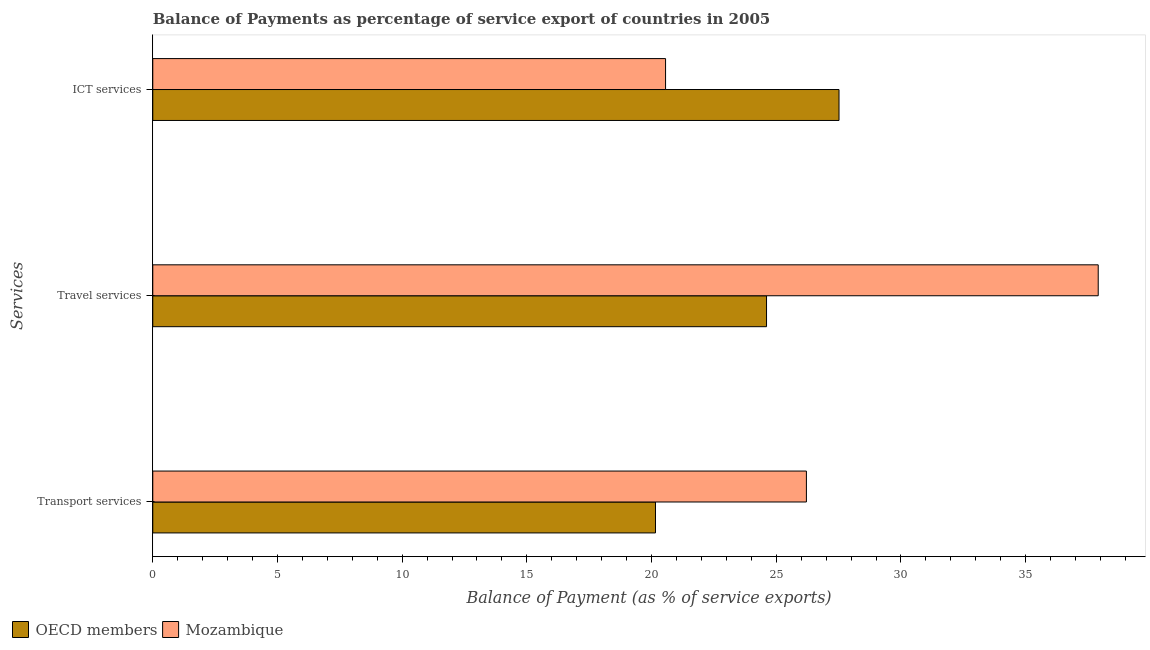How many groups of bars are there?
Keep it short and to the point. 3. Are the number of bars per tick equal to the number of legend labels?
Your answer should be very brief. Yes. Are the number of bars on each tick of the Y-axis equal?
Make the answer very short. Yes. What is the label of the 3rd group of bars from the top?
Your response must be concise. Transport services. What is the balance of payment of ict services in OECD members?
Offer a terse response. 27.52. Across all countries, what is the maximum balance of payment of travel services?
Your answer should be very brief. 37.91. Across all countries, what is the minimum balance of payment of travel services?
Ensure brevity in your answer.  24.61. In which country was the balance of payment of transport services maximum?
Keep it short and to the point. Mozambique. In which country was the balance of payment of travel services minimum?
Offer a very short reply. OECD members. What is the total balance of payment of ict services in the graph?
Provide a short and direct response. 48.08. What is the difference between the balance of payment of transport services in OECD members and that in Mozambique?
Provide a succinct answer. -6.05. What is the difference between the balance of payment of transport services in Mozambique and the balance of payment of travel services in OECD members?
Keep it short and to the point. 1.6. What is the average balance of payment of ict services per country?
Ensure brevity in your answer.  24.04. What is the difference between the balance of payment of transport services and balance of payment of travel services in OECD members?
Your response must be concise. -4.45. What is the ratio of the balance of payment of ict services in OECD members to that in Mozambique?
Make the answer very short. 1.34. Is the difference between the balance of payment of ict services in Mozambique and OECD members greater than the difference between the balance of payment of transport services in Mozambique and OECD members?
Your answer should be compact. No. What is the difference between the highest and the second highest balance of payment of travel services?
Give a very brief answer. 13.3. What is the difference between the highest and the lowest balance of payment of travel services?
Provide a short and direct response. 13.3. In how many countries, is the balance of payment of transport services greater than the average balance of payment of transport services taken over all countries?
Provide a succinct answer. 1. What does the 1st bar from the bottom in ICT services represents?
Your answer should be very brief. OECD members. Is it the case that in every country, the sum of the balance of payment of transport services and balance of payment of travel services is greater than the balance of payment of ict services?
Offer a terse response. Yes. How many bars are there?
Give a very brief answer. 6. Are all the bars in the graph horizontal?
Make the answer very short. Yes. Are the values on the major ticks of X-axis written in scientific E-notation?
Make the answer very short. No. Does the graph contain grids?
Make the answer very short. No. Where does the legend appear in the graph?
Offer a very short reply. Bottom left. How many legend labels are there?
Your answer should be very brief. 2. What is the title of the graph?
Provide a short and direct response. Balance of Payments as percentage of service export of countries in 2005. Does "Romania" appear as one of the legend labels in the graph?
Your response must be concise. No. What is the label or title of the X-axis?
Provide a short and direct response. Balance of Payment (as % of service exports). What is the label or title of the Y-axis?
Your answer should be compact. Services. What is the Balance of Payment (as % of service exports) of OECD members in Transport services?
Make the answer very short. 20.16. What is the Balance of Payment (as % of service exports) in Mozambique in Transport services?
Make the answer very short. 26.21. What is the Balance of Payment (as % of service exports) in OECD members in Travel services?
Offer a terse response. 24.61. What is the Balance of Payment (as % of service exports) in Mozambique in Travel services?
Keep it short and to the point. 37.91. What is the Balance of Payment (as % of service exports) in OECD members in ICT services?
Your answer should be very brief. 27.52. What is the Balance of Payment (as % of service exports) of Mozambique in ICT services?
Keep it short and to the point. 20.56. Across all Services, what is the maximum Balance of Payment (as % of service exports) in OECD members?
Your answer should be very brief. 27.52. Across all Services, what is the maximum Balance of Payment (as % of service exports) of Mozambique?
Make the answer very short. 37.91. Across all Services, what is the minimum Balance of Payment (as % of service exports) of OECD members?
Your answer should be compact. 20.16. Across all Services, what is the minimum Balance of Payment (as % of service exports) in Mozambique?
Make the answer very short. 20.56. What is the total Balance of Payment (as % of service exports) of OECD members in the graph?
Ensure brevity in your answer.  72.29. What is the total Balance of Payment (as % of service exports) of Mozambique in the graph?
Offer a very short reply. 84.68. What is the difference between the Balance of Payment (as % of service exports) in OECD members in Transport services and that in Travel services?
Provide a succinct answer. -4.45. What is the difference between the Balance of Payment (as % of service exports) of Mozambique in Transport services and that in Travel services?
Give a very brief answer. -11.7. What is the difference between the Balance of Payment (as % of service exports) in OECD members in Transport services and that in ICT services?
Make the answer very short. -7.36. What is the difference between the Balance of Payment (as % of service exports) in Mozambique in Transport services and that in ICT services?
Ensure brevity in your answer.  5.65. What is the difference between the Balance of Payment (as % of service exports) in OECD members in Travel services and that in ICT services?
Your response must be concise. -2.91. What is the difference between the Balance of Payment (as % of service exports) in Mozambique in Travel services and that in ICT services?
Give a very brief answer. 17.35. What is the difference between the Balance of Payment (as % of service exports) in OECD members in Transport services and the Balance of Payment (as % of service exports) in Mozambique in Travel services?
Keep it short and to the point. -17.75. What is the difference between the Balance of Payment (as % of service exports) in OECD members in Transport services and the Balance of Payment (as % of service exports) in Mozambique in ICT services?
Give a very brief answer. -0.4. What is the difference between the Balance of Payment (as % of service exports) of OECD members in Travel services and the Balance of Payment (as % of service exports) of Mozambique in ICT services?
Your answer should be compact. 4.05. What is the average Balance of Payment (as % of service exports) in OECD members per Services?
Your answer should be compact. 24.1. What is the average Balance of Payment (as % of service exports) of Mozambique per Services?
Provide a short and direct response. 28.23. What is the difference between the Balance of Payment (as % of service exports) of OECD members and Balance of Payment (as % of service exports) of Mozambique in Transport services?
Your answer should be very brief. -6.05. What is the difference between the Balance of Payment (as % of service exports) in OECD members and Balance of Payment (as % of service exports) in Mozambique in Travel services?
Your answer should be very brief. -13.3. What is the difference between the Balance of Payment (as % of service exports) in OECD members and Balance of Payment (as % of service exports) in Mozambique in ICT services?
Offer a very short reply. 6.96. What is the ratio of the Balance of Payment (as % of service exports) of OECD members in Transport services to that in Travel services?
Your response must be concise. 0.82. What is the ratio of the Balance of Payment (as % of service exports) in Mozambique in Transport services to that in Travel services?
Give a very brief answer. 0.69. What is the ratio of the Balance of Payment (as % of service exports) in OECD members in Transport services to that in ICT services?
Provide a succinct answer. 0.73. What is the ratio of the Balance of Payment (as % of service exports) of Mozambique in Transport services to that in ICT services?
Make the answer very short. 1.27. What is the ratio of the Balance of Payment (as % of service exports) in OECD members in Travel services to that in ICT services?
Your answer should be very brief. 0.89. What is the ratio of the Balance of Payment (as % of service exports) in Mozambique in Travel services to that in ICT services?
Make the answer very short. 1.84. What is the difference between the highest and the second highest Balance of Payment (as % of service exports) of OECD members?
Offer a very short reply. 2.91. What is the difference between the highest and the second highest Balance of Payment (as % of service exports) of Mozambique?
Make the answer very short. 11.7. What is the difference between the highest and the lowest Balance of Payment (as % of service exports) of OECD members?
Your answer should be compact. 7.36. What is the difference between the highest and the lowest Balance of Payment (as % of service exports) of Mozambique?
Provide a succinct answer. 17.35. 